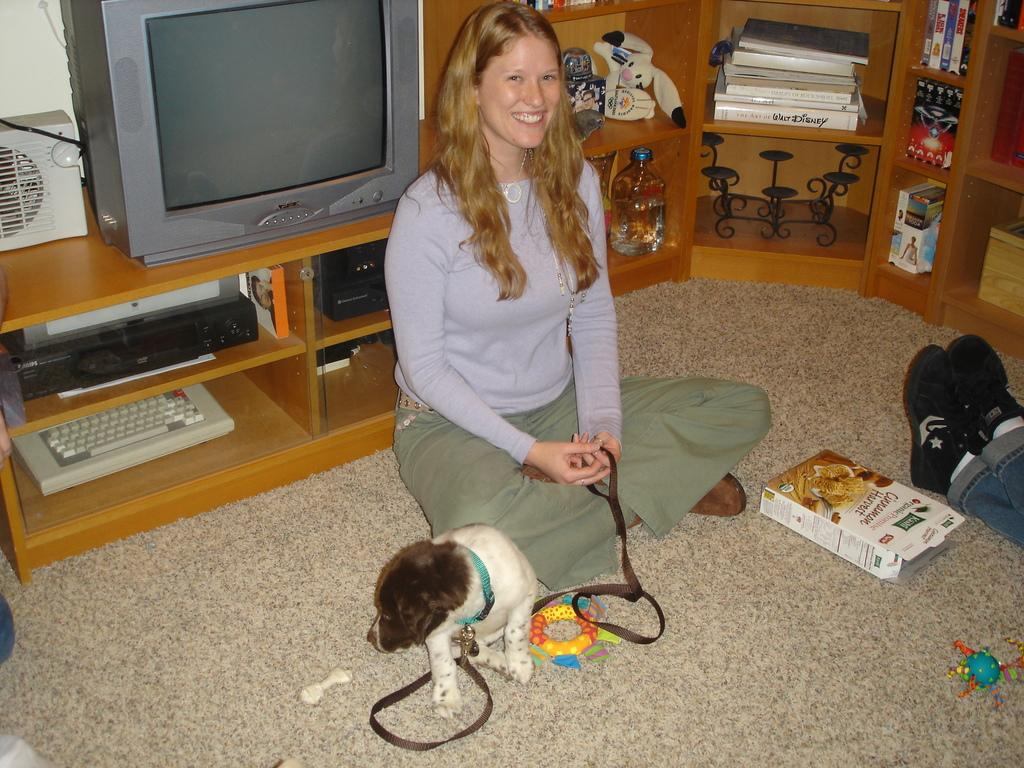What is the woman in the image doing? The woman is sitting on the floor and holding a belt tied to a dog. What objects can be seen behind the woman? There is a TV, books, bottles, toys, and a keyboard behind the woman. What is located on the right side of the image? A person's legs and a box are visible on the right side of the image. How many frogs are jumping on the keyboard in the image? There are no frogs present in the image, and therefore no frogs are jumping on the keyboard. What causes the person to laugh in the image? There is no indication of laughter in the image, and no specific cause can be determined. 